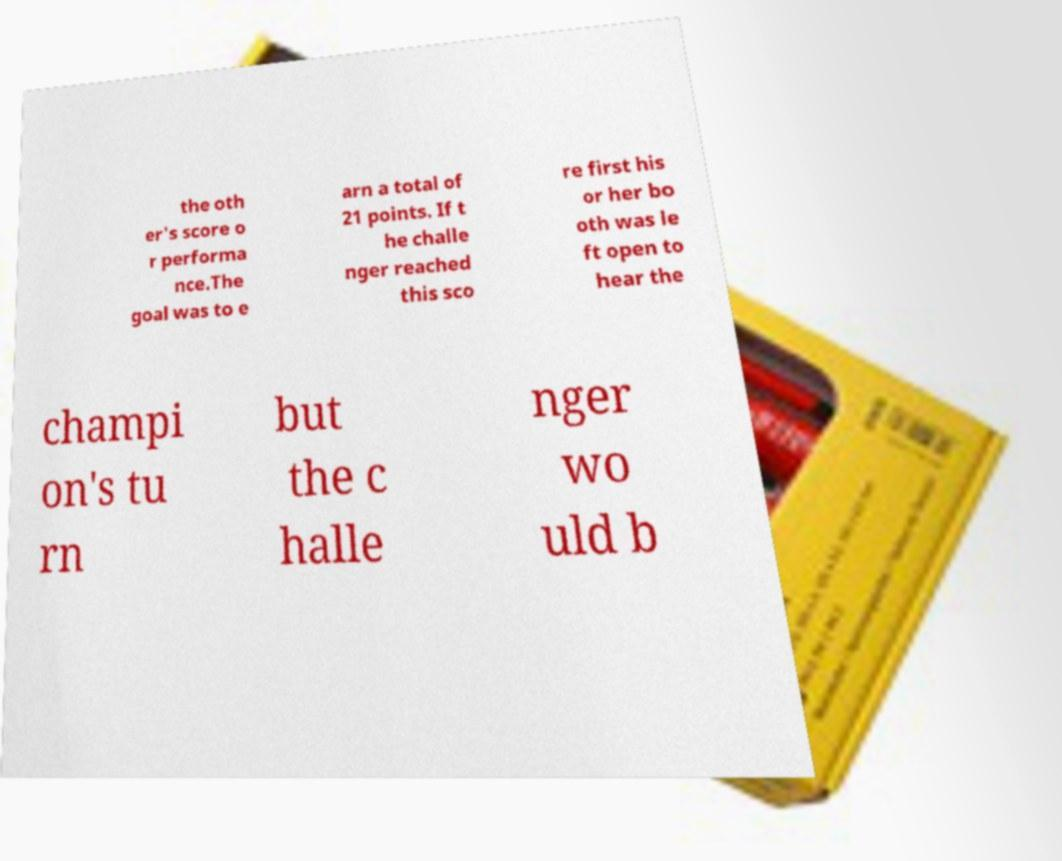Can you accurately transcribe the text from the provided image for me? the oth er's score o r performa nce.The goal was to e arn a total of 21 points. If t he challe nger reached this sco re first his or her bo oth was le ft open to hear the champi on's tu rn but the c halle nger wo uld b 